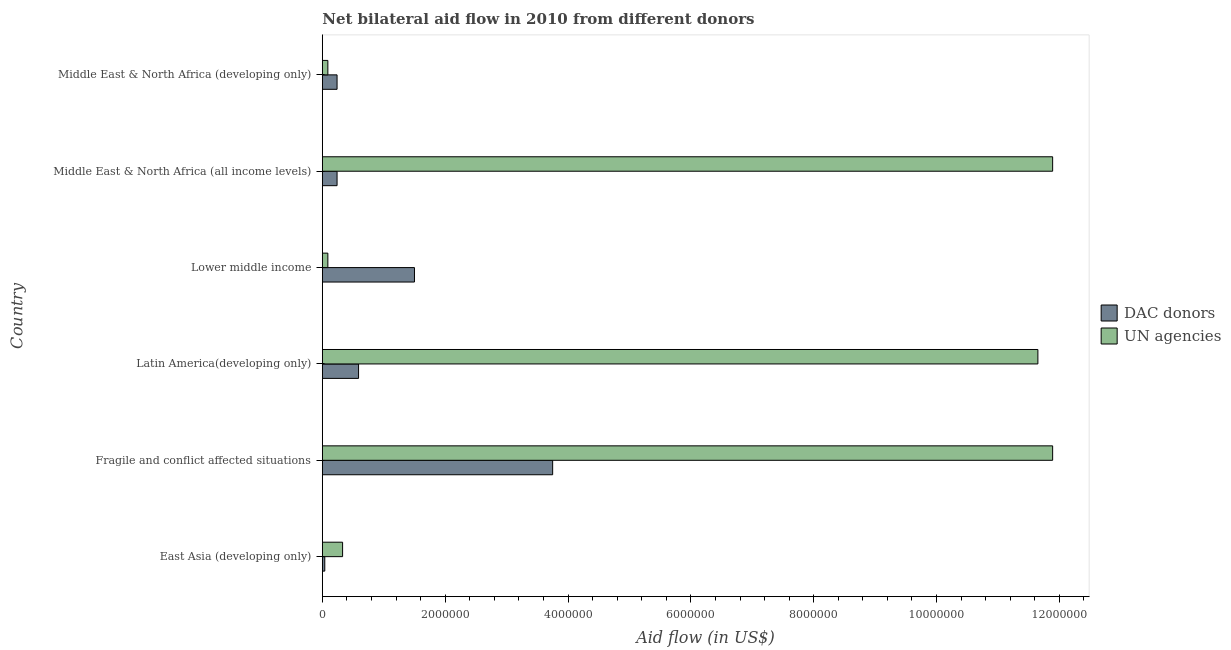How many different coloured bars are there?
Make the answer very short. 2. Are the number of bars per tick equal to the number of legend labels?
Make the answer very short. Yes. How many bars are there on the 4th tick from the top?
Offer a very short reply. 2. What is the label of the 3rd group of bars from the top?
Your answer should be very brief. Lower middle income. In how many cases, is the number of bars for a given country not equal to the number of legend labels?
Give a very brief answer. 0. What is the aid flow from dac donors in East Asia (developing only)?
Your answer should be very brief. 4.00e+04. Across all countries, what is the maximum aid flow from dac donors?
Make the answer very short. 3.75e+06. Across all countries, what is the minimum aid flow from dac donors?
Give a very brief answer. 4.00e+04. In which country was the aid flow from dac donors maximum?
Offer a terse response. Fragile and conflict affected situations. In which country was the aid flow from dac donors minimum?
Ensure brevity in your answer.  East Asia (developing only). What is the total aid flow from un agencies in the graph?
Ensure brevity in your answer.  3.59e+07. What is the difference between the aid flow from un agencies in Lower middle income and that in Middle East & North Africa (all income levels)?
Provide a succinct answer. -1.18e+07. What is the difference between the aid flow from dac donors in Middle East & North Africa (all income levels) and the aid flow from un agencies in Lower middle income?
Make the answer very short. 1.50e+05. What is the average aid flow from dac donors per country?
Make the answer very short. 1.06e+06. What is the difference between the aid flow from un agencies and aid flow from dac donors in Middle East & North Africa (all income levels)?
Your answer should be very brief. 1.16e+07. What is the ratio of the aid flow from un agencies in Latin America(developing only) to that in Middle East & North Africa (developing only)?
Provide a short and direct response. 129.44. Is the aid flow from dac donors in Fragile and conflict affected situations less than that in Lower middle income?
Provide a succinct answer. No. What is the difference between the highest and the second highest aid flow from un agencies?
Your answer should be very brief. 0. What is the difference between the highest and the lowest aid flow from dac donors?
Your response must be concise. 3.71e+06. What does the 1st bar from the top in Fragile and conflict affected situations represents?
Make the answer very short. UN agencies. What does the 2nd bar from the bottom in Middle East & North Africa (all income levels) represents?
Ensure brevity in your answer.  UN agencies. How many bars are there?
Keep it short and to the point. 12. Are all the bars in the graph horizontal?
Offer a terse response. Yes. How many countries are there in the graph?
Your response must be concise. 6. Where does the legend appear in the graph?
Your answer should be very brief. Center right. What is the title of the graph?
Your answer should be compact. Net bilateral aid flow in 2010 from different donors. Does "Tetanus" appear as one of the legend labels in the graph?
Provide a short and direct response. No. What is the label or title of the X-axis?
Your answer should be compact. Aid flow (in US$). What is the label or title of the Y-axis?
Your answer should be compact. Country. What is the Aid flow (in US$) in UN agencies in East Asia (developing only)?
Make the answer very short. 3.30e+05. What is the Aid flow (in US$) of DAC donors in Fragile and conflict affected situations?
Your answer should be compact. 3.75e+06. What is the Aid flow (in US$) in UN agencies in Fragile and conflict affected situations?
Provide a succinct answer. 1.19e+07. What is the Aid flow (in US$) of DAC donors in Latin America(developing only)?
Your answer should be compact. 5.90e+05. What is the Aid flow (in US$) in UN agencies in Latin America(developing only)?
Offer a terse response. 1.16e+07. What is the Aid flow (in US$) in DAC donors in Lower middle income?
Ensure brevity in your answer.  1.50e+06. What is the Aid flow (in US$) in UN agencies in Lower middle income?
Provide a short and direct response. 9.00e+04. What is the Aid flow (in US$) of DAC donors in Middle East & North Africa (all income levels)?
Your answer should be very brief. 2.40e+05. What is the Aid flow (in US$) in UN agencies in Middle East & North Africa (all income levels)?
Provide a short and direct response. 1.19e+07. What is the Aid flow (in US$) in DAC donors in Middle East & North Africa (developing only)?
Your response must be concise. 2.40e+05. Across all countries, what is the maximum Aid flow (in US$) of DAC donors?
Give a very brief answer. 3.75e+06. Across all countries, what is the maximum Aid flow (in US$) of UN agencies?
Ensure brevity in your answer.  1.19e+07. What is the total Aid flow (in US$) of DAC donors in the graph?
Make the answer very short. 6.36e+06. What is the total Aid flow (in US$) of UN agencies in the graph?
Ensure brevity in your answer.  3.59e+07. What is the difference between the Aid flow (in US$) in DAC donors in East Asia (developing only) and that in Fragile and conflict affected situations?
Ensure brevity in your answer.  -3.71e+06. What is the difference between the Aid flow (in US$) of UN agencies in East Asia (developing only) and that in Fragile and conflict affected situations?
Give a very brief answer. -1.16e+07. What is the difference between the Aid flow (in US$) in DAC donors in East Asia (developing only) and that in Latin America(developing only)?
Ensure brevity in your answer.  -5.50e+05. What is the difference between the Aid flow (in US$) in UN agencies in East Asia (developing only) and that in Latin America(developing only)?
Ensure brevity in your answer.  -1.13e+07. What is the difference between the Aid flow (in US$) in DAC donors in East Asia (developing only) and that in Lower middle income?
Provide a short and direct response. -1.46e+06. What is the difference between the Aid flow (in US$) of UN agencies in East Asia (developing only) and that in Lower middle income?
Make the answer very short. 2.40e+05. What is the difference between the Aid flow (in US$) of UN agencies in East Asia (developing only) and that in Middle East & North Africa (all income levels)?
Offer a very short reply. -1.16e+07. What is the difference between the Aid flow (in US$) of DAC donors in East Asia (developing only) and that in Middle East & North Africa (developing only)?
Make the answer very short. -2.00e+05. What is the difference between the Aid flow (in US$) of DAC donors in Fragile and conflict affected situations and that in Latin America(developing only)?
Your response must be concise. 3.16e+06. What is the difference between the Aid flow (in US$) of UN agencies in Fragile and conflict affected situations and that in Latin America(developing only)?
Give a very brief answer. 2.40e+05. What is the difference between the Aid flow (in US$) in DAC donors in Fragile and conflict affected situations and that in Lower middle income?
Offer a terse response. 2.25e+06. What is the difference between the Aid flow (in US$) of UN agencies in Fragile and conflict affected situations and that in Lower middle income?
Provide a short and direct response. 1.18e+07. What is the difference between the Aid flow (in US$) of DAC donors in Fragile and conflict affected situations and that in Middle East & North Africa (all income levels)?
Ensure brevity in your answer.  3.51e+06. What is the difference between the Aid flow (in US$) of DAC donors in Fragile and conflict affected situations and that in Middle East & North Africa (developing only)?
Provide a short and direct response. 3.51e+06. What is the difference between the Aid flow (in US$) in UN agencies in Fragile and conflict affected situations and that in Middle East & North Africa (developing only)?
Provide a short and direct response. 1.18e+07. What is the difference between the Aid flow (in US$) in DAC donors in Latin America(developing only) and that in Lower middle income?
Make the answer very short. -9.10e+05. What is the difference between the Aid flow (in US$) in UN agencies in Latin America(developing only) and that in Lower middle income?
Give a very brief answer. 1.16e+07. What is the difference between the Aid flow (in US$) of DAC donors in Latin America(developing only) and that in Middle East & North Africa (all income levels)?
Offer a terse response. 3.50e+05. What is the difference between the Aid flow (in US$) in UN agencies in Latin America(developing only) and that in Middle East & North Africa (all income levels)?
Make the answer very short. -2.40e+05. What is the difference between the Aid flow (in US$) in DAC donors in Latin America(developing only) and that in Middle East & North Africa (developing only)?
Provide a short and direct response. 3.50e+05. What is the difference between the Aid flow (in US$) in UN agencies in Latin America(developing only) and that in Middle East & North Africa (developing only)?
Give a very brief answer. 1.16e+07. What is the difference between the Aid flow (in US$) of DAC donors in Lower middle income and that in Middle East & North Africa (all income levels)?
Keep it short and to the point. 1.26e+06. What is the difference between the Aid flow (in US$) of UN agencies in Lower middle income and that in Middle East & North Africa (all income levels)?
Your answer should be very brief. -1.18e+07. What is the difference between the Aid flow (in US$) of DAC donors in Lower middle income and that in Middle East & North Africa (developing only)?
Your answer should be very brief. 1.26e+06. What is the difference between the Aid flow (in US$) in UN agencies in Middle East & North Africa (all income levels) and that in Middle East & North Africa (developing only)?
Make the answer very short. 1.18e+07. What is the difference between the Aid flow (in US$) in DAC donors in East Asia (developing only) and the Aid flow (in US$) in UN agencies in Fragile and conflict affected situations?
Offer a terse response. -1.18e+07. What is the difference between the Aid flow (in US$) of DAC donors in East Asia (developing only) and the Aid flow (in US$) of UN agencies in Latin America(developing only)?
Your answer should be compact. -1.16e+07. What is the difference between the Aid flow (in US$) in DAC donors in East Asia (developing only) and the Aid flow (in US$) in UN agencies in Lower middle income?
Keep it short and to the point. -5.00e+04. What is the difference between the Aid flow (in US$) of DAC donors in East Asia (developing only) and the Aid flow (in US$) of UN agencies in Middle East & North Africa (all income levels)?
Make the answer very short. -1.18e+07. What is the difference between the Aid flow (in US$) of DAC donors in Fragile and conflict affected situations and the Aid flow (in US$) of UN agencies in Latin America(developing only)?
Your response must be concise. -7.90e+06. What is the difference between the Aid flow (in US$) of DAC donors in Fragile and conflict affected situations and the Aid flow (in US$) of UN agencies in Lower middle income?
Your answer should be very brief. 3.66e+06. What is the difference between the Aid flow (in US$) in DAC donors in Fragile and conflict affected situations and the Aid flow (in US$) in UN agencies in Middle East & North Africa (all income levels)?
Offer a terse response. -8.14e+06. What is the difference between the Aid flow (in US$) of DAC donors in Fragile and conflict affected situations and the Aid flow (in US$) of UN agencies in Middle East & North Africa (developing only)?
Offer a very short reply. 3.66e+06. What is the difference between the Aid flow (in US$) in DAC donors in Latin America(developing only) and the Aid flow (in US$) in UN agencies in Middle East & North Africa (all income levels)?
Your answer should be compact. -1.13e+07. What is the difference between the Aid flow (in US$) in DAC donors in Latin America(developing only) and the Aid flow (in US$) in UN agencies in Middle East & North Africa (developing only)?
Your answer should be compact. 5.00e+05. What is the difference between the Aid flow (in US$) in DAC donors in Lower middle income and the Aid flow (in US$) in UN agencies in Middle East & North Africa (all income levels)?
Ensure brevity in your answer.  -1.04e+07. What is the difference between the Aid flow (in US$) of DAC donors in Lower middle income and the Aid flow (in US$) of UN agencies in Middle East & North Africa (developing only)?
Provide a short and direct response. 1.41e+06. What is the difference between the Aid flow (in US$) in DAC donors in Middle East & North Africa (all income levels) and the Aid flow (in US$) in UN agencies in Middle East & North Africa (developing only)?
Offer a very short reply. 1.50e+05. What is the average Aid flow (in US$) in DAC donors per country?
Ensure brevity in your answer.  1.06e+06. What is the average Aid flow (in US$) of UN agencies per country?
Provide a short and direct response. 5.99e+06. What is the difference between the Aid flow (in US$) of DAC donors and Aid flow (in US$) of UN agencies in East Asia (developing only)?
Keep it short and to the point. -2.90e+05. What is the difference between the Aid flow (in US$) of DAC donors and Aid flow (in US$) of UN agencies in Fragile and conflict affected situations?
Offer a very short reply. -8.14e+06. What is the difference between the Aid flow (in US$) of DAC donors and Aid flow (in US$) of UN agencies in Latin America(developing only)?
Offer a very short reply. -1.11e+07. What is the difference between the Aid flow (in US$) of DAC donors and Aid flow (in US$) of UN agencies in Lower middle income?
Give a very brief answer. 1.41e+06. What is the difference between the Aid flow (in US$) of DAC donors and Aid flow (in US$) of UN agencies in Middle East & North Africa (all income levels)?
Make the answer very short. -1.16e+07. What is the ratio of the Aid flow (in US$) of DAC donors in East Asia (developing only) to that in Fragile and conflict affected situations?
Make the answer very short. 0.01. What is the ratio of the Aid flow (in US$) of UN agencies in East Asia (developing only) to that in Fragile and conflict affected situations?
Give a very brief answer. 0.03. What is the ratio of the Aid flow (in US$) in DAC donors in East Asia (developing only) to that in Latin America(developing only)?
Ensure brevity in your answer.  0.07. What is the ratio of the Aid flow (in US$) of UN agencies in East Asia (developing only) to that in Latin America(developing only)?
Provide a short and direct response. 0.03. What is the ratio of the Aid flow (in US$) in DAC donors in East Asia (developing only) to that in Lower middle income?
Offer a very short reply. 0.03. What is the ratio of the Aid flow (in US$) of UN agencies in East Asia (developing only) to that in Lower middle income?
Make the answer very short. 3.67. What is the ratio of the Aid flow (in US$) of UN agencies in East Asia (developing only) to that in Middle East & North Africa (all income levels)?
Make the answer very short. 0.03. What is the ratio of the Aid flow (in US$) of UN agencies in East Asia (developing only) to that in Middle East & North Africa (developing only)?
Give a very brief answer. 3.67. What is the ratio of the Aid flow (in US$) in DAC donors in Fragile and conflict affected situations to that in Latin America(developing only)?
Provide a short and direct response. 6.36. What is the ratio of the Aid flow (in US$) in UN agencies in Fragile and conflict affected situations to that in Latin America(developing only)?
Ensure brevity in your answer.  1.02. What is the ratio of the Aid flow (in US$) of UN agencies in Fragile and conflict affected situations to that in Lower middle income?
Ensure brevity in your answer.  132.11. What is the ratio of the Aid flow (in US$) in DAC donors in Fragile and conflict affected situations to that in Middle East & North Africa (all income levels)?
Your response must be concise. 15.62. What is the ratio of the Aid flow (in US$) in DAC donors in Fragile and conflict affected situations to that in Middle East & North Africa (developing only)?
Offer a terse response. 15.62. What is the ratio of the Aid flow (in US$) in UN agencies in Fragile and conflict affected situations to that in Middle East & North Africa (developing only)?
Provide a short and direct response. 132.11. What is the ratio of the Aid flow (in US$) in DAC donors in Latin America(developing only) to that in Lower middle income?
Your response must be concise. 0.39. What is the ratio of the Aid flow (in US$) in UN agencies in Latin America(developing only) to that in Lower middle income?
Offer a very short reply. 129.44. What is the ratio of the Aid flow (in US$) in DAC donors in Latin America(developing only) to that in Middle East & North Africa (all income levels)?
Provide a succinct answer. 2.46. What is the ratio of the Aid flow (in US$) in UN agencies in Latin America(developing only) to that in Middle East & North Africa (all income levels)?
Provide a short and direct response. 0.98. What is the ratio of the Aid flow (in US$) of DAC donors in Latin America(developing only) to that in Middle East & North Africa (developing only)?
Your answer should be compact. 2.46. What is the ratio of the Aid flow (in US$) in UN agencies in Latin America(developing only) to that in Middle East & North Africa (developing only)?
Your answer should be compact. 129.44. What is the ratio of the Aid flow (in US$) of DAC donors in Lower middle income to that in Middle East & North Africa (all income levels)?
Provide a short and direct response. 6.25. What is the ratio of the Aid flow (in US$) in UN agencies in Lower middle income to that in Middle East & North Africa (all income levels)?
Give a very brief answer. 0.01. What is the ratio of the Aid flow (in US$) in DAC donors in Lower middle income to that in Middle East & North Africa (developing only)?
Your answer should be very brief. 6.25. What is the ratio of the Aid flow (in US$) of DAC donors in Middle East & North Africa (all income levels) to that in Middle East & North Africa (developing only)?
Provide a succinct answer. 1. What is the ratio of the Aid flow (in US$) of UN agencies in Middle East & North Africa (all income levels) to that in Middle East & North Africa (developing only)?
Your answer should be compact. 132.11. What is the difference between the highest and the second highest Aid flow (in US$) of DAC donors?
Ensure brevity in your answer.  2.25e+06. What is the difference between the highest and the lowest Aid flow (in US$) of DAC donors?
Provide a succinct answer. 3.71e+06. What is the difference between the highest and the lowest Aid flow (in US$) of UN agencies?
Your answer should be very brief. 1.18e+07. 